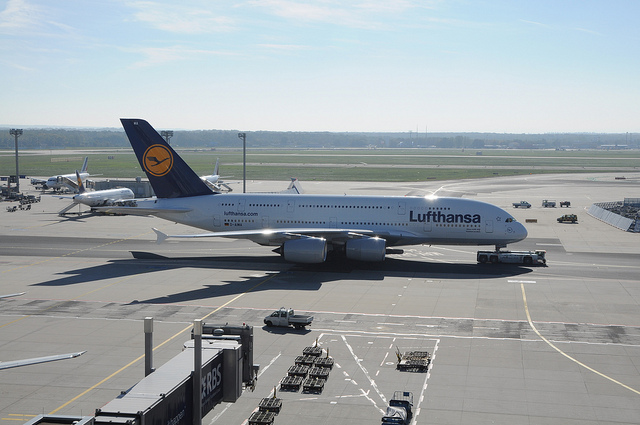Please transcribe the text information in this image. Lufthansa RBS 